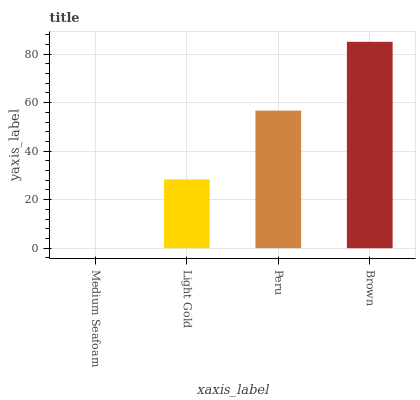Is Light Gold the minimum?
Answer yes or no. No. Is Light Gold the maximum?
Answer yes or no. No. Is Light Gold greater than Medium Seafoam?
Answer yes or no. Yes. Is Medium Seafoam less than Light Gold?
Answer yes or no. Yes. Is Medium Seafoam greater than Light Gold?
Answer yes or no. No. Is Light Gold less than Medium Seafoam?
Answer yes or no. No. Is Peru the high median?
Answer yes or no. Yes. Is Light Gold the low median?
Answer yes or no. Yes. Is Brown the high median?
Answer yes or no. No. Is Brown the low median?
Answer yes or no. No. 